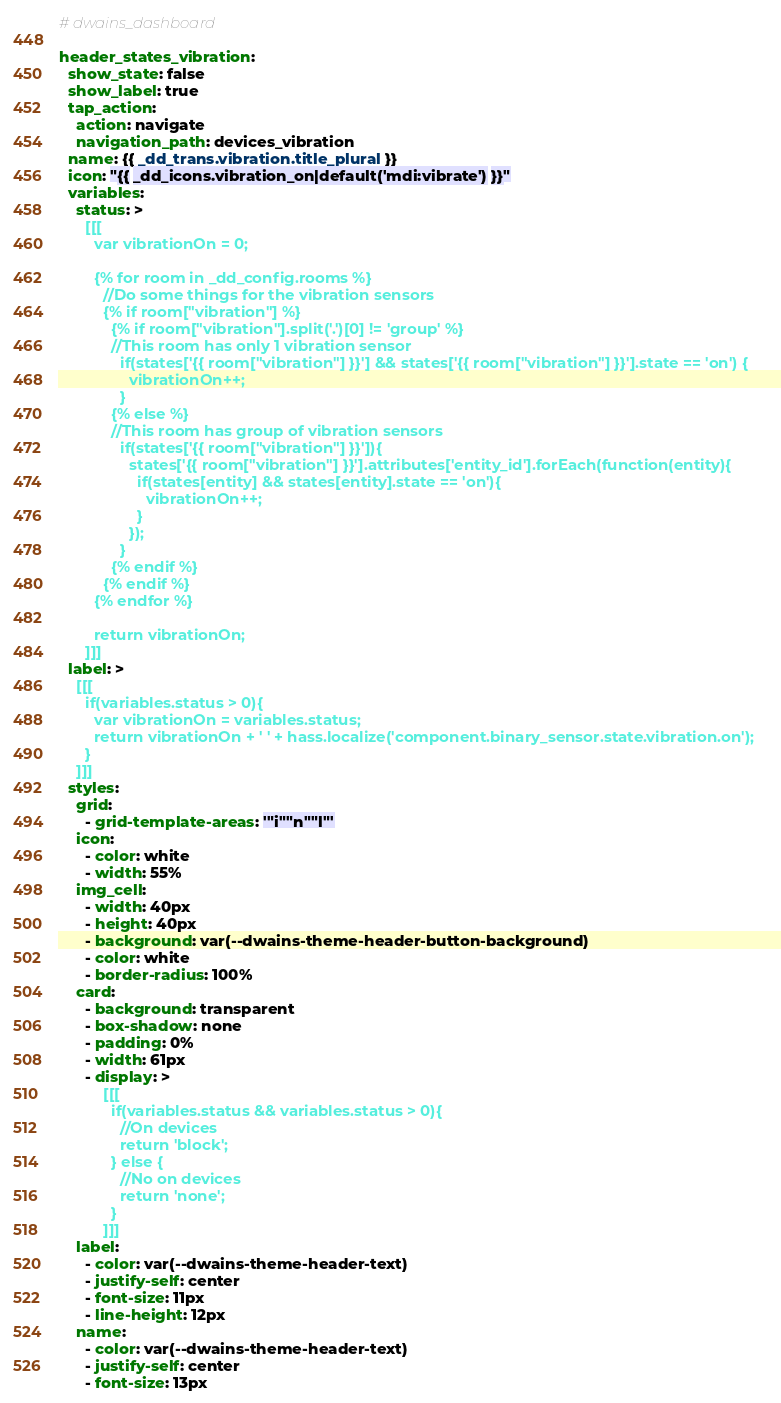Convert code to text. <code><loc_0><loc_0><loc_500><loc_500><_YAML_># dwains_dashboard

header_states_vibration:
  show_state: false
  show_label: true
  tap_action: 
    action: navigate
    navigation_path: devices_vibration
  name: {{ _dd_trans.vibration.title_plural }}
  icon: "{{ _dd_icons.vibration_on|default('mdi:vibrate') }}"
  variables:
    status: >
      [[[
        var vibrationOn = 0;

        {% for room in _dd_config.rooms %}                        
          //Do some things for the vibration sensors
          {% if room["vibration"] %}
            {% if room["vibration"].split('.')[0] != 'group' %}
            //This room has only 1 vibration sensor
              if(states['{{ room["vibration"] }}'] && states['{{ room["vibration"] }}'].state == 'on') {
                vibrationOn++;
              }
            {% else %}
            //This room has group of vibration sensors
              if(states['{{ room["vibration"] }}']){
                states['{{ room["vibration"] }}'].attributes['entity_id'].forEach(function(entity){
                  if(states[entity] && states[entity].state == 'on'){
                    vibrationOn++;
                  }
                });  
              }
            {% endif %}
          {% endif %}
        {% endfor %}

        return vibrationOn;
      ]]]
  label: >
    [[[
      if(variables.status > 0){
        var vibrationOn = variables.status;
        return vibrationOn + ' ' + hass.localize('component.binary_sensor.state.vibration.on');
      }
    ]]]
  styles:
    grid:
      - grid-template-areas: '"i""n""l"'
    icon:
      - color: white
      - width: 55%
    img_cell:
      - width: 40px
      - height: 40px
      - background: var(--dwains-theme-header-button-background)
      - color: white
      - border-radius: 100%
    card:
      - background: transparent
      - box-shadow: none
      - padding: 0%
      - width: 61px
      - display: >
          [[[
            if(variables.status && variables.status > 0){
              //On devices
              return 'block';
            } else {
              //No on devices
              return 'none';
            }
          ]]]
    label:
      - color: var(--dwains-theme-header-text)
      - justify-self: center
      - font-size: 11px
      - line-height: 12px
    name:
      - color: var(--dwains-theme-header-text)
      - justify-self: center
      - font-size: 13px</code> 